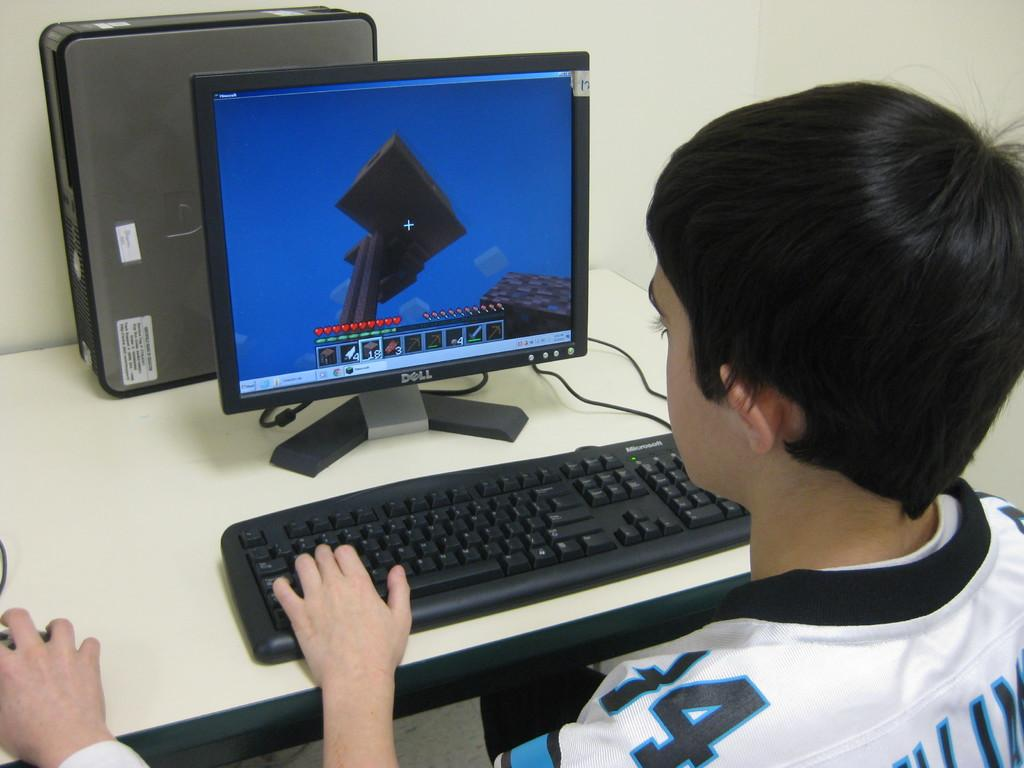<image>
Present a compact description of the photo's key features. a boy at a computer with the number 4 on his jersey 